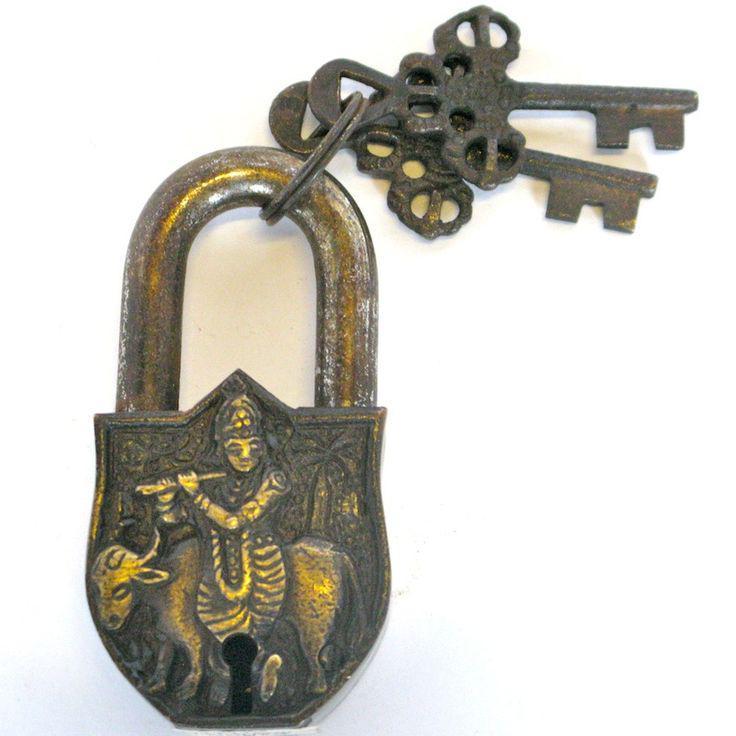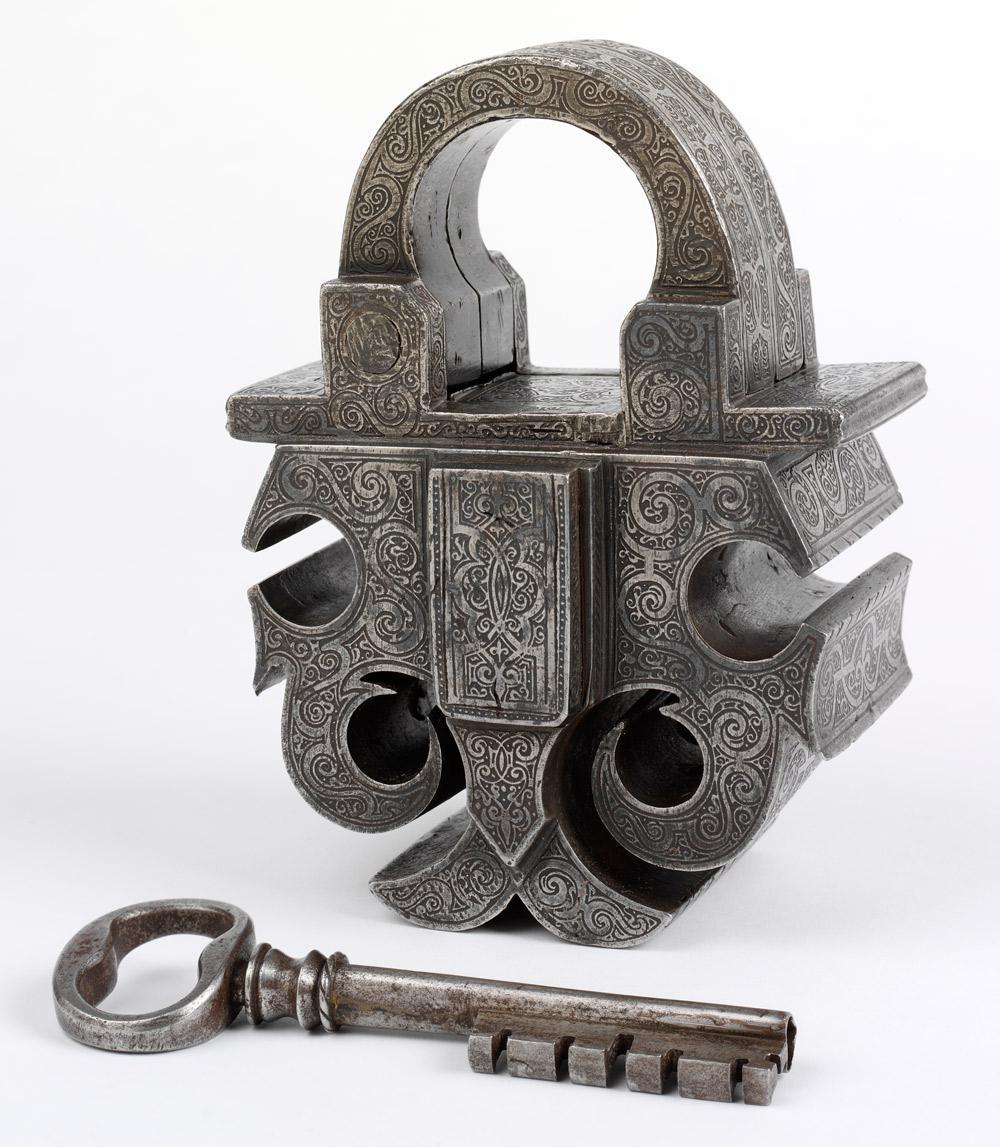The first image is the image on the left, the second image is the image on the right. For the images shown, is this caption "An image shows a lock decorated with a human-like figure on its front and with a keyring attached." true? Answer yes or no. Yes. The first image is the image on the left, the second image is the image on the right. Given the left and right images, does the statement "In one of the images there is a lock with an image carved on the front and two keys attached to it." hold true? Answer yes or no. Yes. 